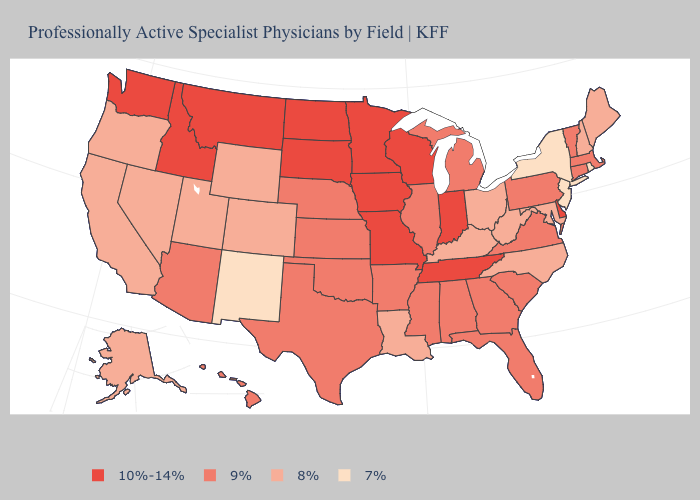Does Nebraska have the lowest value in the MidWest?
Be succinct. No. Name the states that have a value in the range 7%?
Write a very short answer. New Jersey, New Mexico, New York, Rhode Island. Does Vermont have a lower value than Louisiana?
Quick response, please. No. Does South Dakota have the highest value in the USA?
Write a very short answer. Yes. Does Indiana have the highest value in the MidWest?
Quick response, please. Yes. What is the value of New Hampshire?
Keep it brief. 8%. Does Tennessee have the highest value in the South?
Be succinct. Yes. Does California have the highest value in the USA?
Short answer required. No. Which states have the lowest value in the USA?
Keep it brief. New Jersey, New Mexico, New York, Rhode Island. Which states hav the highest value in the West?
Write a very short answer. Idaho, Montana, Washington. Name the states that have a value in the range 8%?
Give a very brief answer. Alaska, California, Colorado, Kentucky, Louisiana, Maine, Maryland, Nevada, New Hampshire, North Carolina, Ohio, Oregon, Utah, West Virginia, Wyoming. Does the first symbol in the legend represent the smallest category?
Concise answer only. No. Does the first symbol in the legend represent the smallest category?
Concise answer only. No. Name the states that have a value in the range 9%?
Be succinct. Alabama, Arizona, Arkansas, Connecticut, Florida, Georgia, Hawaii, Illinois, Kansas, Massachusetts, Michigan, Mississippi, Nebraska, Oklahoma, Pennsylvania, South Carolina, Texas, Vermont, Virginia. Among the states that border North Dakota , which have the highest value?
Short answer required. Minnesota, Montana, South Dakota. 